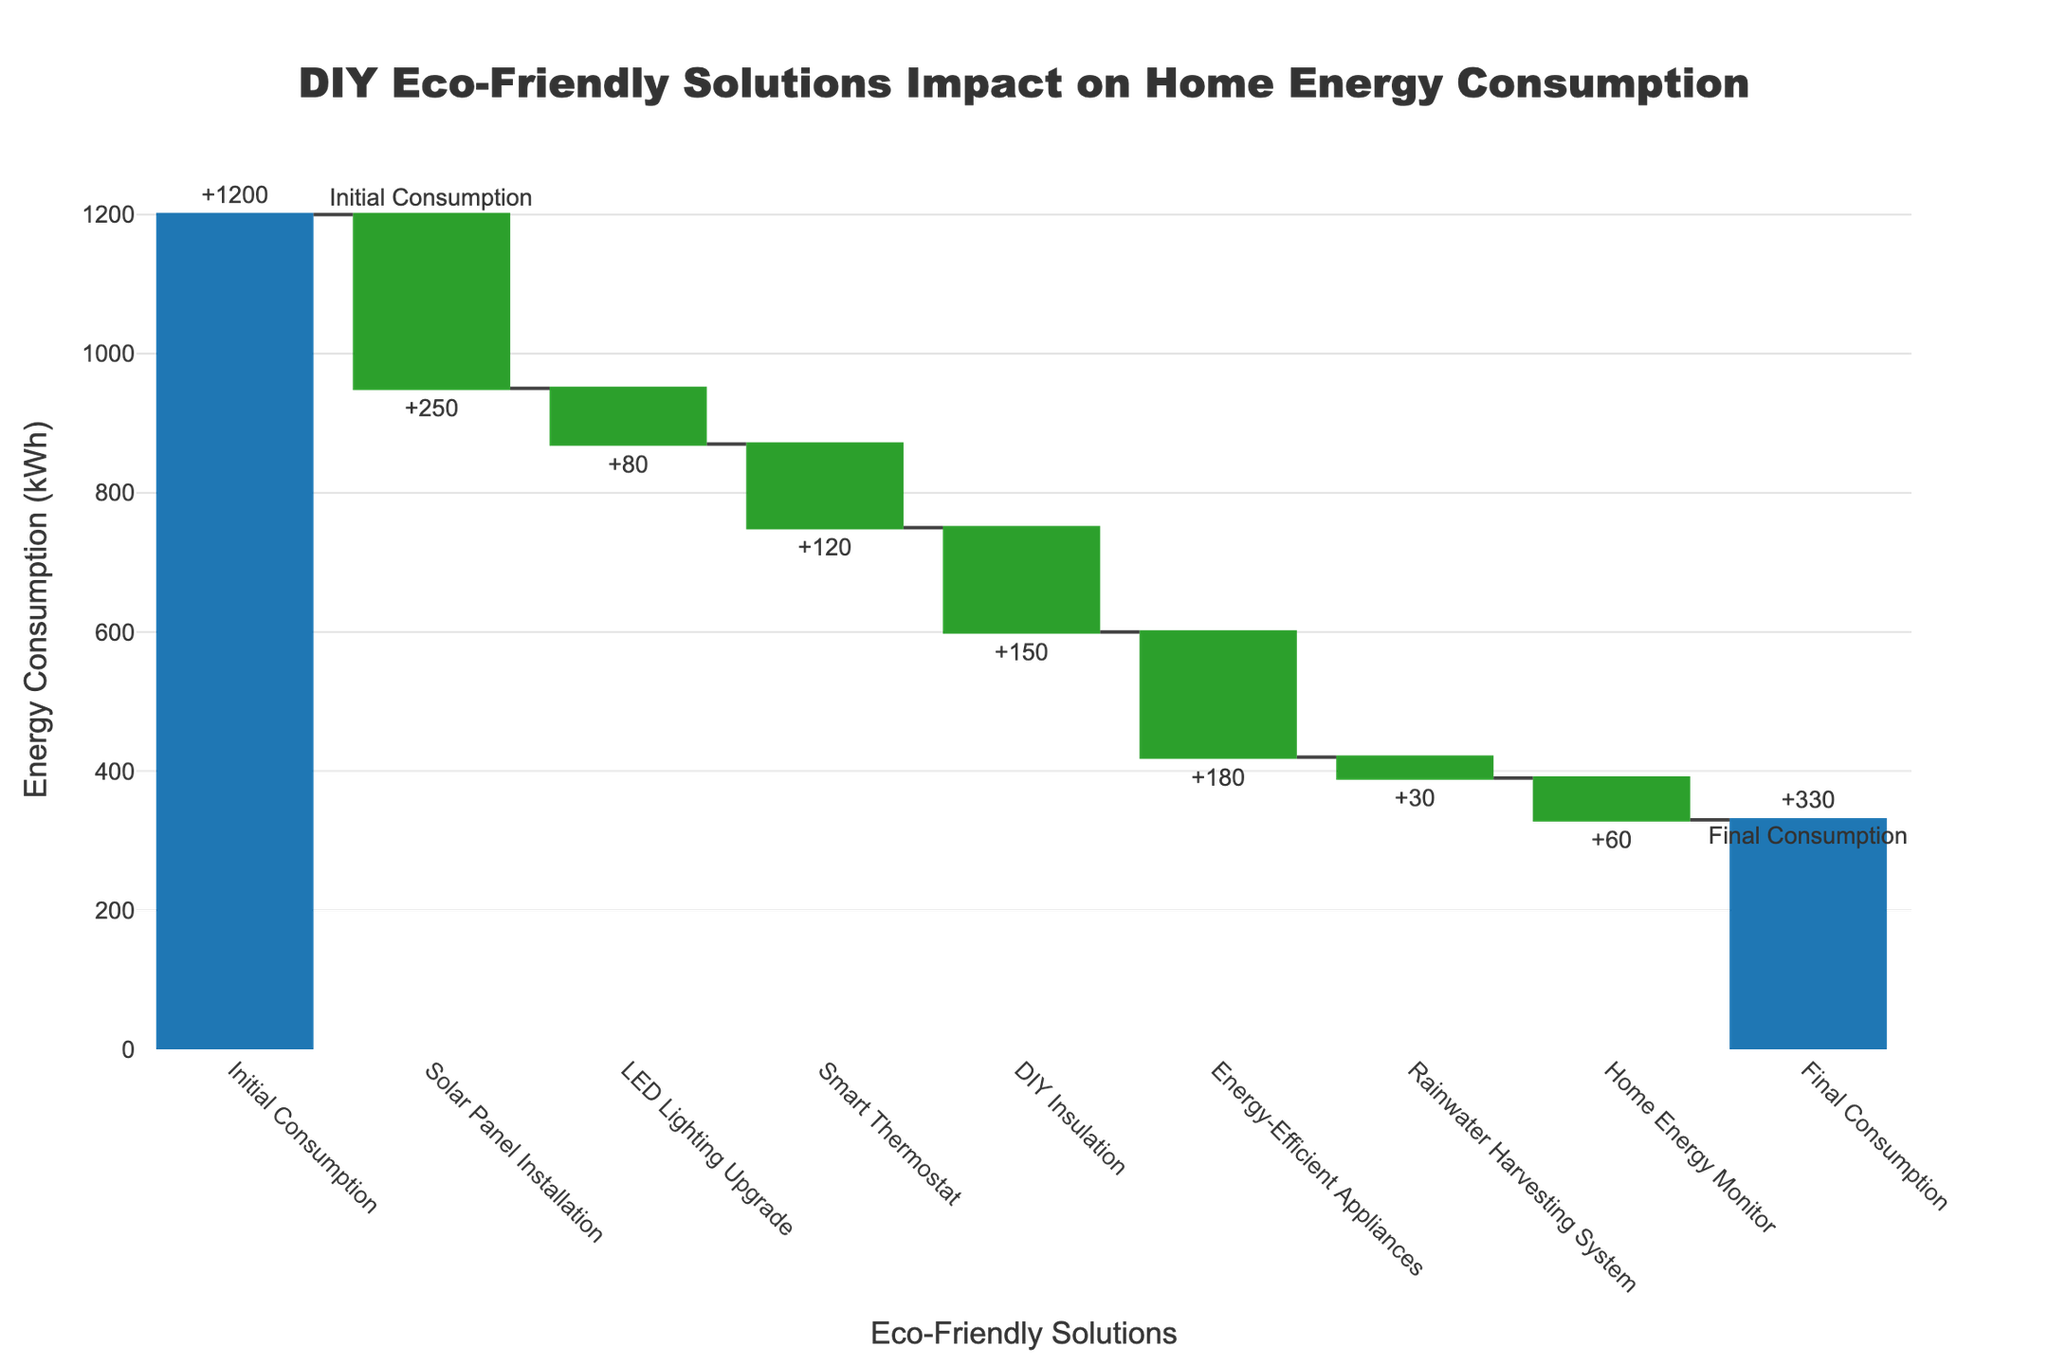What is the title of the figure? The title of the figure is located at the top and typically provides a summary of the visualization. Reading the title directly from the top of the chart gives the information.
Answer: DIY Eco-Friendly Solutions Impact on Home Energy Consumption How many total DIY solutions were implemented to reduce energy consumption? The categories on the x-axis represent the different DIY solutions implemented. By counting the categories excluding "Initial Consumption" and "Final Consumption," we can determine the number of solutions.
Answer: 7 What is the initial energy consumption before any DIY solutions were implemented? The initial energy consumption is indicated by the first bar labeled "Initial Consumption" on the left side of the chart. The value at the top of this bar shows the initial consumption.
Answer: 1200 kWh How much did the solar panel installation contribute to the reduction in energy consumption? The impact of the solar panel installation is shown as a negative value on the y-axis, specifically by the bar labeled "Solar Panel Installation." The value on this bar shows the reduction amount.
Answer: 250 kWh What is the final energy consumption after all DIY solutions were implemented? The final energy consumption is represented by the last bar labeled "Final Consumption" on the right side of the chart. The value at the top of this bar shows the final consumption.
Answer: 330 kWh Which DIY solution contributed the most to reducing energy consumption? To identify the solution with the maximum reduction, compare the negative values of all the bars labeled with specific DIY solutions. The solution with the largest negative value is the one that contributed the most.
Answer: Solar Panel Installation What is the total reduction in energy consumption achieved by all the DIY solutions combined? The total reduction is the difference between the initial consumption and the final consumption. By subtracting the final consumption value from the initial consumption value, we get the total reduction.
Answer: 870 kWh How does the impact of energy-efficient appliances compare to that of the smart thermostat? To compare these two solutions, look at the respective bars for "Energy-Efficient Appliances" and "Smart Thermostat" and compare their negative values. The solution with the higher negative value had a greater impact.
Answer: Energy-Efficient Appliances had a greater impact (180 kWh vs. 120 kWh) What is the average reduction per DIY solution implemented? The average reduction can be calculated by summing up all the reductions and dividing by the number of DIY solutions. The total reduction is 870 kWh across 7 solutions. Dividing 870 by 7 gives the average reduction.
Answer: 124.3 kWh Which solutions did not have a significant impact on the energy consumption reduction, and how can their impact be described? To identify less impactful solutions, look at the bars with the smallest negative values. Smaller reductions indicate less impact. Solutions like "Rainwater Harvesting System" and "Home Energy Monitor" have lower reduction values compared to others.
Answer: Rainwater Harvesting System (-30 kWh) and Home Energy Monitor (-60 kWh) are less impactful 